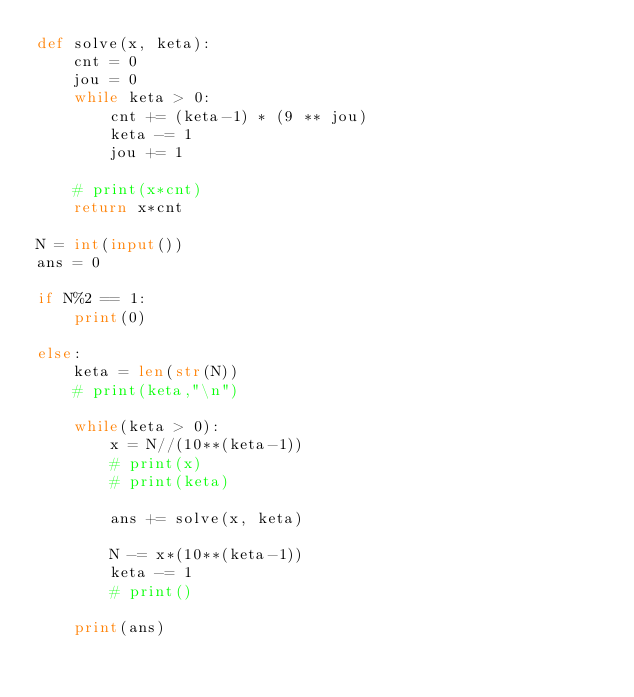<code> <loc_0><loc_0><loc_500><loc_500><_Python_>def solve(x, keta):
    cnt = 0
    jou = 0
    while keta > 0:
        cnt += (keta-1) * (9 ** jou)
        keta -= 1
        jou += 1

    # print(x*cnt)
    return x*cnt

N = int(input())
ans = 0

if N%2 == 1:
    print(0)

else:
    keta = len(str(N))
    # print(keta,"\n")

    while(keta > 0):
        x = N//(10**(keta-1))
        # print(x)
        # print(keta)

        ans += solve(x, keta)

        N -= x*(10**(keta-1))
        keta -= 1
        # print()

    print(ans)</code> 